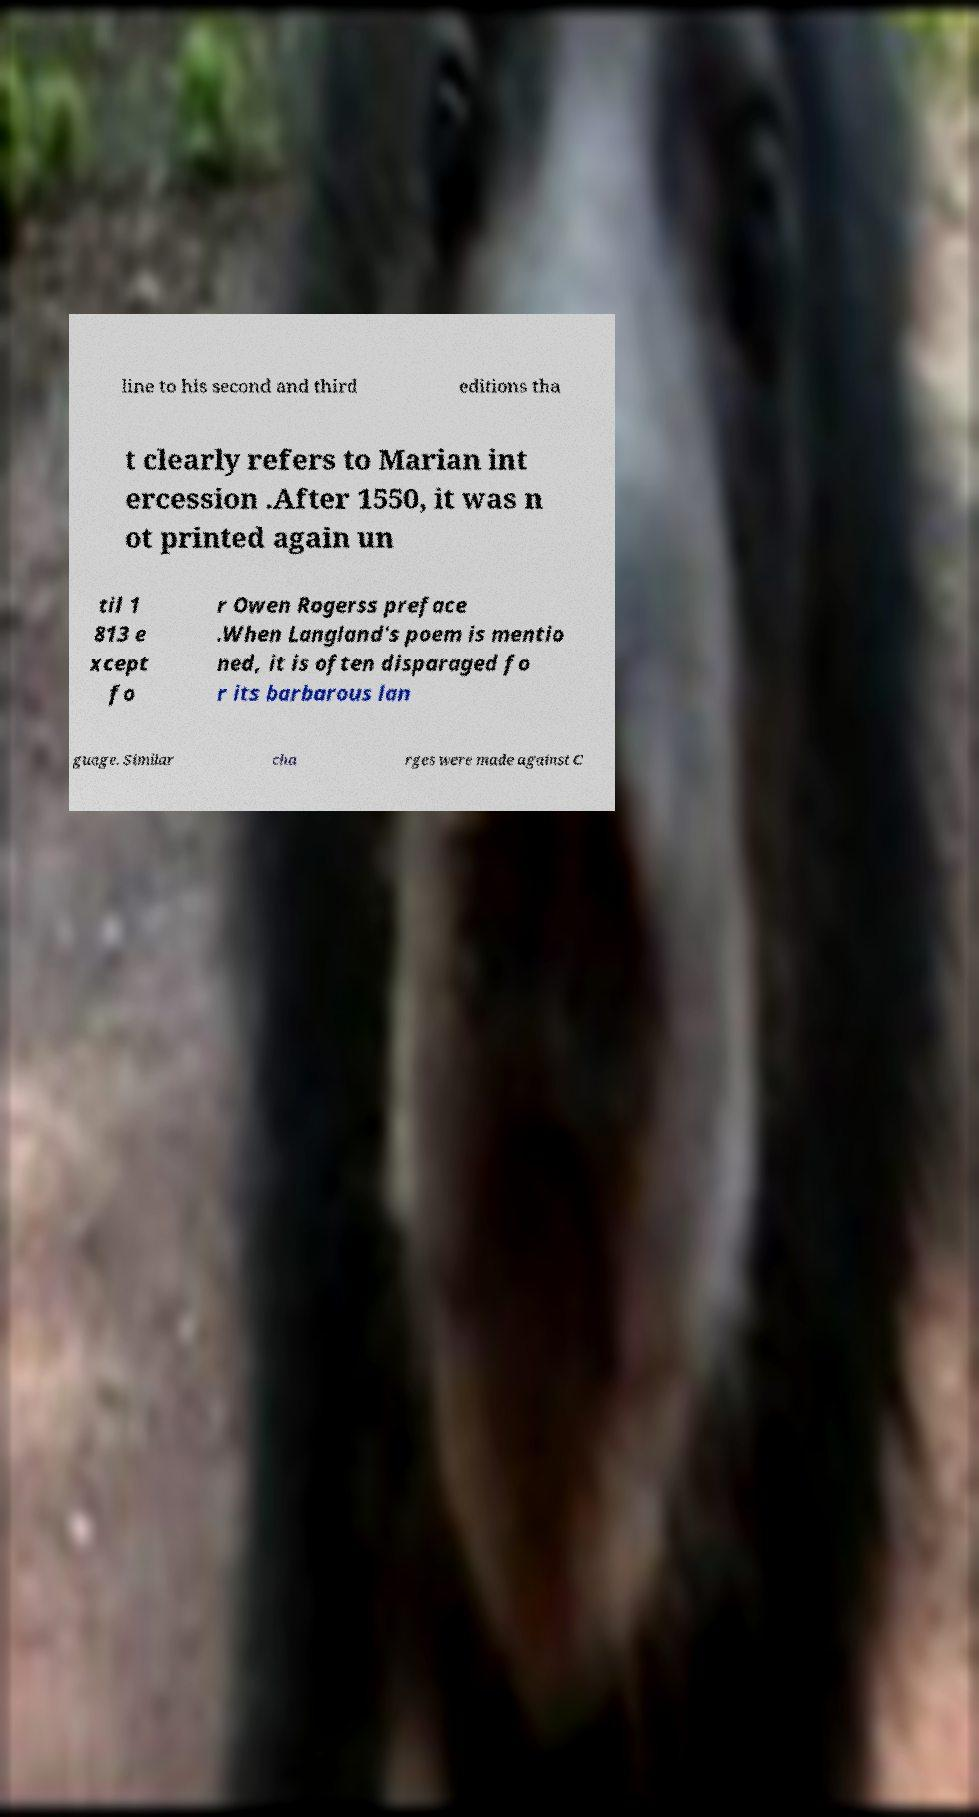There's text embedded in this image that I need extracted. Can you transcribe it verbatim? line to his second and third editions tha t clearly refers to Marian int ercession .After 1550, it was n ot printed again un til 1 813 e xcept fo r Owen Rogerss preface .When Langland's poem is mentio ned, it is often disparaged fo r its barbarous lan guage. Similar cha rges were made against C 